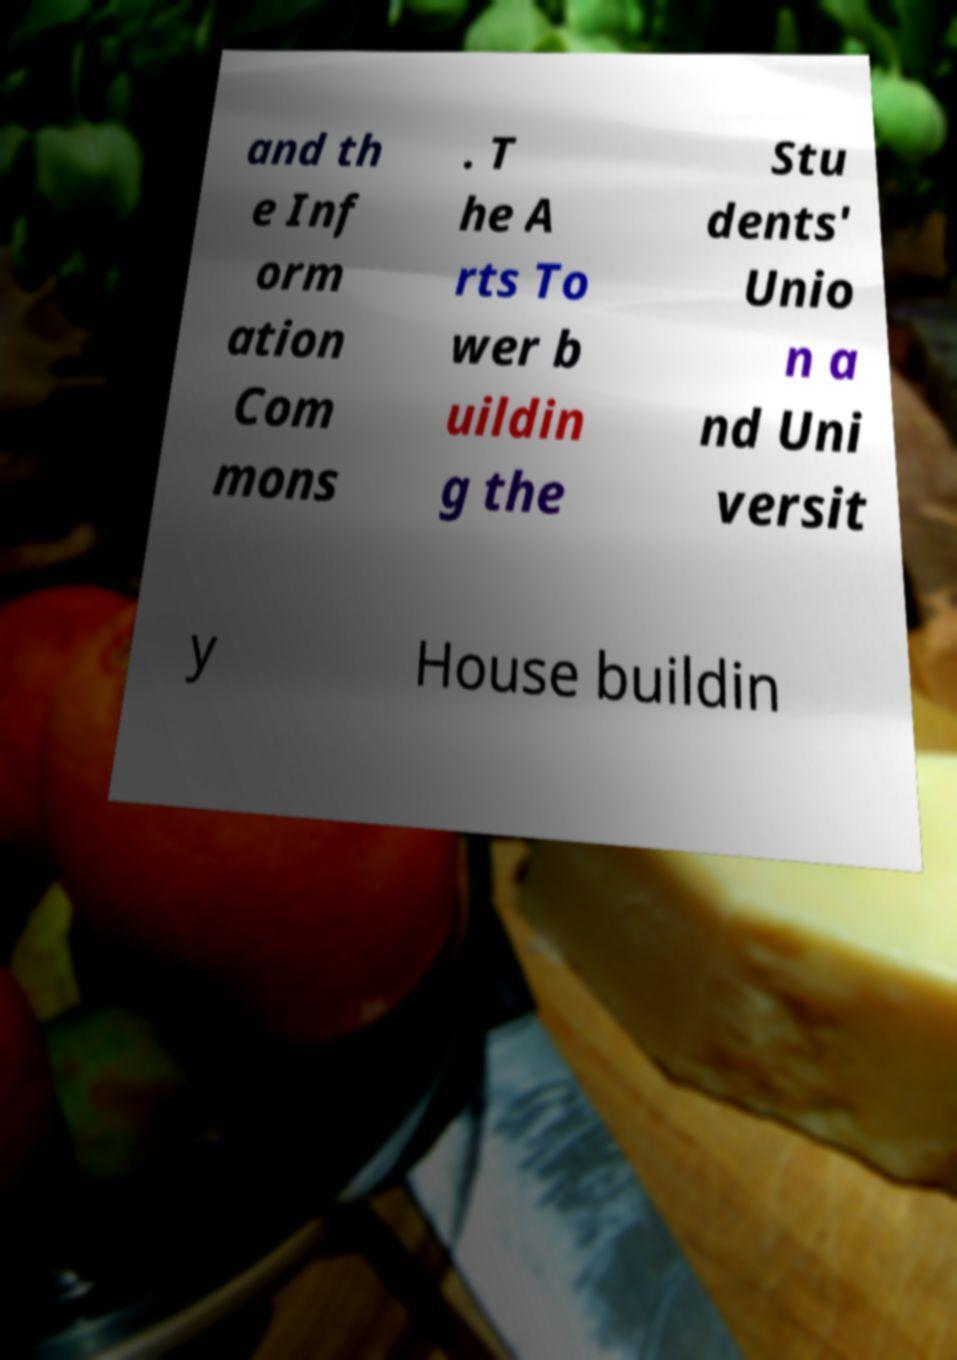What messages or text are displayed in this image? I need them in a readable, typed format. and th e Inf orm ation Com mons . T he A rts To wer b uildin g the Stu dents' Unio n a nd Uni versit y House buildin 